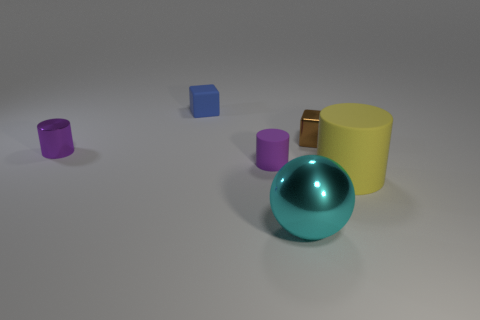Add 3 large blue shiny things. How many objects exist? 9 Subtract all spheres. How many objects are left? 5 Add 2 yellow cylinders. How many yellow cylinders are left? 3 Add 3 red objects. How many red objects exist? 3 Subtract 1 yellow cylinders. How many objects are left? 5 Subtract all tiny purple matte spheres. Subtract all cyan things. How many objects are left? 5 